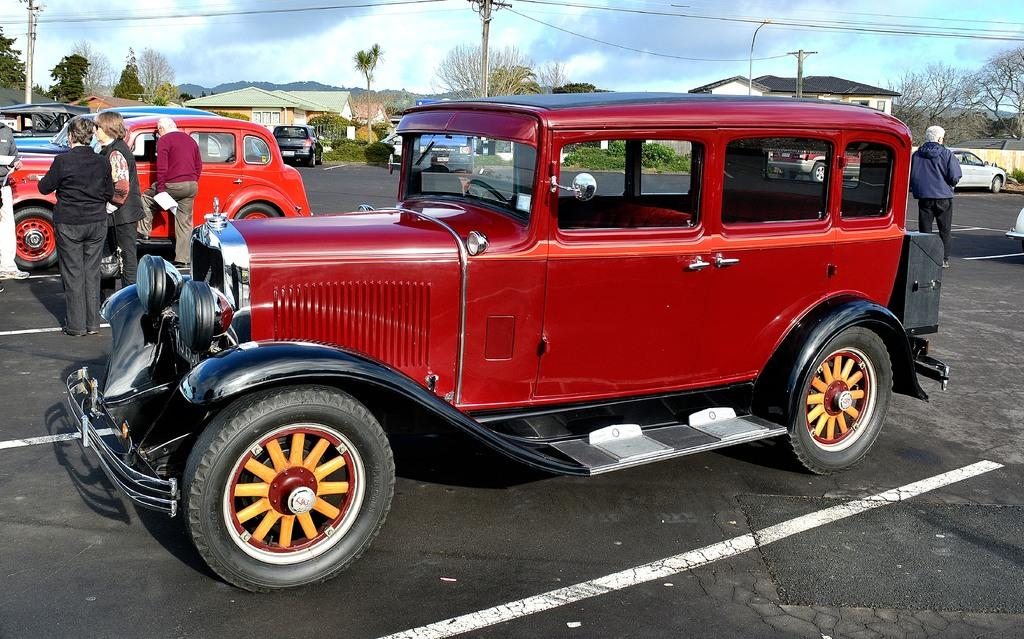What can be seen in the image? There are persons standing in the image, along with vehicles on the road. What is visible in the background of the image? In the background, there are houses, trees, poles, wires, and the sky. What is the condition of the sky in the image? The sky is visible in the background of the image, and clouds are present. What type of coat is being worn by the person in the image? There is no coat visible in the image; the persons standing in the image are not wearing any coats. What need does the sink in the image fulfill? There is no sink present in the image; it only features persons, vehicles, houses, trees, poles, wires, and the sky. 